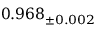<formula> <loc_0><loc_0><loc_500><loc_500>0 . 9 6 8 _ { \pm 0 . 0 0 2 }</formula> 